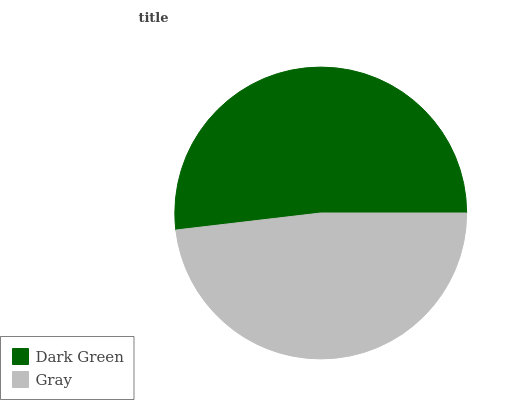Is Gray the minimum?
Answer yes or no. Yes. Is Dark Green the maximum?
Answer yes or no. Yes. Is Gray the maximum?
Answer yes or no. No. Is Dark Green greater than Gray?
Answer yes or no. Yes. Is Gray less than Dark Green?
Answer yes or no. Yes. Is Gray greater than Dark Green?
Answer yes or no. No. Is Dark Green less than Gray?
Answer yes or no. No. Is Dark Green the high median?
Answer yes or no. Yes. Is Gray the low median?
Answer yes or no. Yes. Is Gray the high median?
Answer yes or no. No. Is Dark Green the low median?
Answer yes or no. No. 